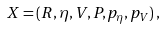Convert formula to latex. <formula><loc_0><loc_0><loc_500><loc_500>X = ( R , \eta , V , P , p _ { \eta } , p _ { V } ) \, ,</formula> 